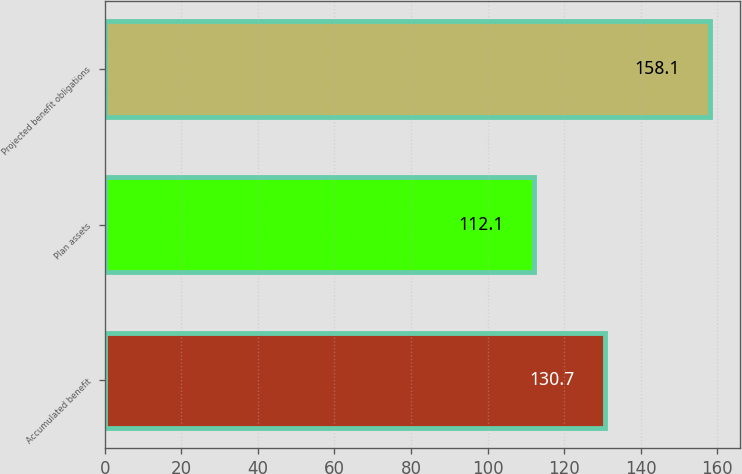Convert chart. <chart><loc_0><loc_0><loc_500><loc_500><bar_chart><fcel>Accumulated benefit<fcel>Plan assets<fcel>Projected benefit obligations<nl><fcel>130.7<fcel>112.1<fcel>158.1<nl></chart> 